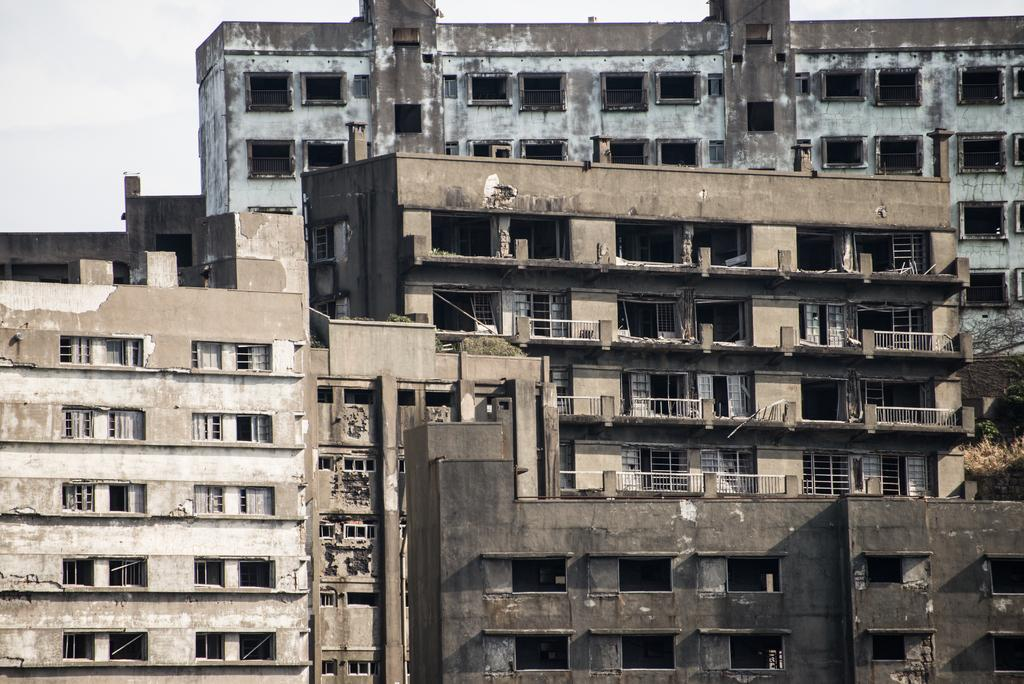What type of structures are present in the image? There are tall buildings in the image. How are the buildings positioned in relation to each other? The buildings are beside each other. What feature can be observed at the bottom of one building? There are holes at the bottom of one building. Can you describe the appearance of the buildings? The buildings appear to be old. What color is the eye of the person standing next to the buildings in the image? There is no person or eye visible in the image; it only features tall buildings. 